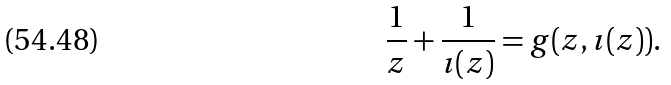Convert formula to latex. <formula><loc_0><loc_0><loc_500><loc_500>\frac { 1 } { z } + \frac { 1 } { \imath ( z ) } = g ( z , \imath ( z ) ) .</formula> 